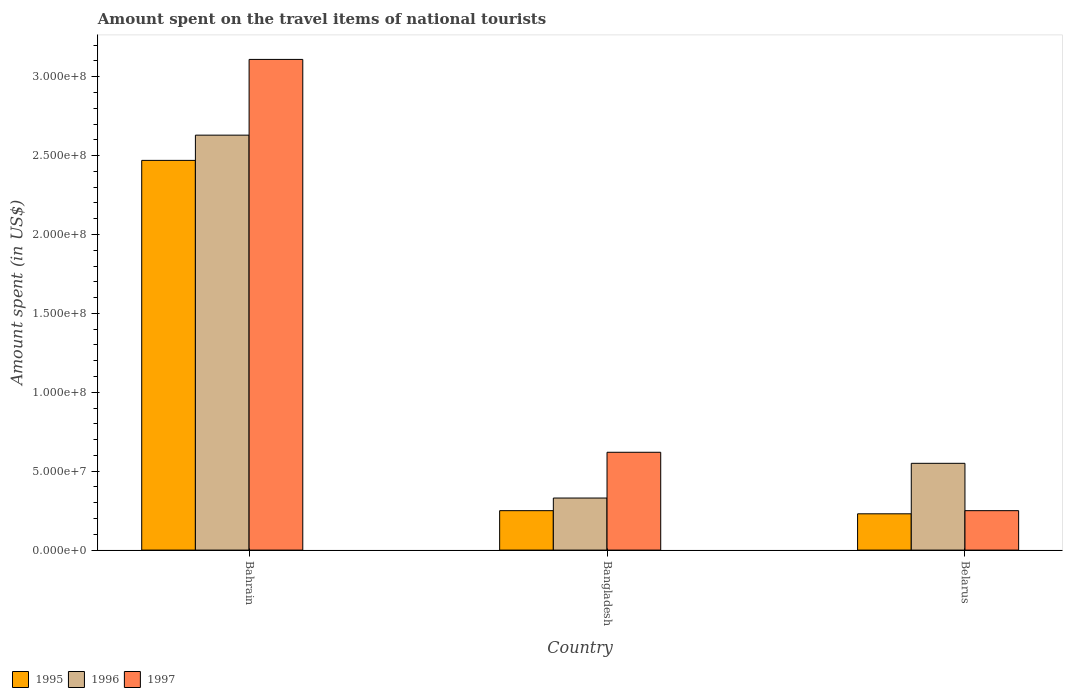How many different coloured bars are there?
Your answer should be compact. 3. What is the label of the 3rd group of bars from the left?
Offer a terse response. Belarus. What is the amount spent on the travel items of national tourists in 1996 in Belarus?
Offer a very short reply. 5.50e+07. Across all countries, what is the maximum amount spent on the travel items of national tourists in 1997?
Your response must be concise. 3.11e+08. Across all countries, what is the minimum amount spent on the travel items of national tourists in 1996?
Your answer should be compact. 3.30e+07. In which country was the amount spent on the travel items of national tourists in 1997 maximum?
Provide a succinct answer. Bahrain. In which country was the amount spent on the travel items of national tourists in 1995 minimum?
Make the answer very short. Belarus. What is the total amount spent on the travel items of national tourists in 1995 in the graph?
Ensure brevity in your answer.  2.95e+08. What is the difference between the amount spent on the travel items of national tourists in 1995 in Bahrain and that in Bangladesh?
Provide a short and direct response. 2.22e+08. What is the difference between the amount spent on the travel items of national tourists in 1996 in Bahrain and the amount spent on the travel items of national tourists in 1995 in Belarus?
Your answer should be compact. 2.40e+08. What is the average amount spent on the travel items of national tourists in 1997 per country?
Provide a succinct answer. 1.33e+08. What is the difference between the amount spent on the travel items of national tourists of/in 1995 and amount spent on the travel items of national tourists of/in 1996 in Bangladesh?
Make the answer very short. -8.00e+06. In how many countries, is the amount spent on the travel items of national tourists in 1996 greater than 60000000 US$?
Your answer should be very brief. 1. What is the ratio of the amount spent on the travel items of national tourists in 1995 in Bahrain to that in Bangladesh?
Make the answer very short. 9.88. What is the difference between the highest and the second highest amount spent on the travel items of national tourists in 1996?
Make the answer very short. 2.30e+08. What is the difference between the highest and the lowest amount spent on the travel items of national tourists in 1997?
Keep it short and to the point. 2.86e+08. Is the sum of the amount spent on the travel items of national tourists in 1996 in Bahrain and Bangladesh greater than the maximum amount spent on the travel items of national tourists in 1995 across all countries?
Ensure brevity in your answer.  Yes. What does the 3rd bar from the right in Belarus represents?
Offer a terse response. 1995. Is it the case that in every country, the sum of the amount spent on the travel items of national tourists in 1996 and amount spent on the travel items of national tourists in 1997 is greater than the amount spent on the travel items of national tourists in 1995?
Your response must be concise. Yes. How many bars are there?
Offer a very short reply. 9. How many countries are there in the graph?
Ensure brevity in your answer.  3. What is the difference between two consecutive major ticks on the Y-axis?
Offer a very short reply. 5.00e+07. Are the values on the major ticks of Y-axis written in scientific E-notation?
Offer a terse response. Yes. Does the graph contain any zero values?
Offer a very short reply. No. Does the graph contain grids?
Keep it short and to the point. No. How many legend labels are there?
Provide a short and direct response. 3. What is the title of the graph?
Make the answer very short. Amount spent on the travel items of national tourists. What is the label or title of the Y-axis?
Your response must be concise. Amount spent (in US$). What is the Amount spent (in US$) in 1995 in Bahrain?
Make the answer very short. 2.47e+08. What is the Amount spent (in US$) in 1996 in Bahrain?
Offer a terse response. 2.63e+08. What is the Amount spent (in US$) of 1997 in Bahrain?
Your response must be concise. 3.11e+08. What is the Amount spent (in US$) in 1995 in Bangladesh?
Your answer should be compact. 2.50e+07. What is the Amount spent (in US$) of 1996 in Bangladesh?
Offer a terse response. 3.30e+07. What is the Amount spent (in US$) of 1997 in Bangladesh?
Your answer should be compact. 6.20e+07. What is the Amount spent (in US$) in 1995 in Belarus?
Make the answer very short. 2.30e+07. What is the Amount spent (in US$) in 1996 in Belarus?
Your answer should be compact. 5.50e+07. What is the Amount spent (in US$) in 1997 in Belarus?
Ensure brevity in your answer.  2.50e+07. Across all countries, what is the maximum Amount spent (in US$) of 1995?
Provide a succinct answer. 2.47e+08. Across all countries, what is the maximum Amount spent (in US$) of 1996?
Provide a short and direct response. 2.63e+08. Across all countries, what is the maximum Amount spent (in US$) of 1997?
Your answer should be compact. 3.11e+08. Across all countries, what is the minimum Amount spent (in US$) in 1995?
Ensure brevity in your answer.  2.30e+07. Across all countries, what is the minimum Amount spent (in US$) of 1996?
Provide a short and direct response. 3.30e+07. Across all countries, what is the minimum Amount spent (in US$) of 1997?
Provide a short and direct response. 2.50e+07. What is the total Amount spent (in US$) of 1995 in the graph?
Make the answer very short. 2.95e+08. What is the total Amount spent (in US$) of 1996 in the graph?
Make the answer very short. 3.51e+08. What is the total Amount spent (in US$) of 1997 in the graph?
Your response must be concise. 3.98e+08. What is the difference between the Amount spent (in US$) in 1995 in Bahrain and that in Bangladesh?
Ensure brevity in your answer.  2.22e+08. What is the difference between the Amount spent (in US$) in 1996 in Bahrain and that in Bangladesh?
Make the answer very short. 2.30e+08. What is the difference between the Amount spent (in US$) of 1997 in Bahrain and that in Bangladesh?
Your answer should be very brief. 2.49e+08. What is the difference between the Amount spent (in US$) in 1995 in Bahrain and that in Belarus?
Provide a short and direct response. 2.24e+08. What is the difference between the Amount spent (in US$) in 1996 in Bahrain and that in Belarus?
Offer a terse response. 2.08e+08. What is the difference between the Amount spent (in US$) in 1997 in Bahrain and that in Belarus?
Keep it short and to the point. 2.86e+08. What is the difference between the Amount spent (in US$) in 1995 in Bangladesh and that in Belarus?
Give a very brief answer. 2.00e+06. What is the difference between the Amount spent (in US$) of 1996 in Bangladesh and that in Belarus?
Your answer should be very brief. -2.20e+07. What is the difference between the Amount spent (in US$) in 1997 in Bangladesh and that in Belarus?
Ensure brevity in your answer.  3.70e+07. What is the difference between the Amount spent (in US$) in 1995 in Bahrain and the Amount spent (in US$) in 1996 in Bangladesh?
Your answer should be compact. 2.14e+08. What is the difference between the Amount spent (in US$) in 1995 in Bahrain and the Amount spent (in US$) in 1997 in Bangladesh?
Offer a terse response. 1.85e+08. What is the difference between the Amount spent (in US$) in 1996 in Bahrain and the Amount spent (in US$) in 1997 in Bangladesh?
Make the answer very short. 2.01e+08. What is the difference between the Amount spent (in US$) of 1995 in Bahrain and the Amount spent (in US$) of 1996 in Belarus?
Give a very brief answer. 1.92e+08. What is the difference between the Amount spent (in US$) of 1995 in Bahrain and the Amount spent (in US$) of 1997 in Belarus?
Ensure brevity in your answer.  2.22e+08. What is the difference between the Amount spent (in US$) of 1996 in Bahrain and the Amount spent (in US$) of 1997 in Belarus?
Provide a short and direct response. 2.38e+08. What is the difference between the Amount spent (in US$) in 1995 in Bangladesh and the Amount spent (in US$) in 1996 in Belarus?
Offer a terse response. -3.00e+07. What is the difference between the Amount spent (in US$) of 1996 in Bangladesh and the Amount spent (in US$) of 1997 in Belarus?
Make the answer very short. 8.00e+06. What is the average Amount spent (in US$) in 1995 per country?
Give a very brief answer. 9.83e+07. What is the average Amount spent (in US$) in 1996 per country?
Provide a succinct answer. 1.17e+08. What is the average Amount spent (in US$) of 1997 per country?
Provide a short and direct response. 1.33e+08. What is the difference between the Amount spent (in US$) of 1995 and Amount spent (in US$) of 1996 in Bahrain?
Your answer should be compact. -1.60e+07. What is the difference between the Amount spent (in US$) of 1995 and Amount spent (in US$) of 1997 in Bahrain?
Your answer should be very brief. -6.40e+07. What is the difference between the Amount spent (in US$) in 1996 and Amount spent (in US$) in 1997 in Bahrain?
Your answer should be compact. -4.80e+07. What is the difference between the Amount spent (in US$) in 1995 and Amount spent (in US$) in 1996 in Bangladesh?
Your answer should be very brief. -8.00e+06. What is the difference between the Amount spent (in US$) in 1995 and Amount spent (in US$) in 1997 in Bangladesh?
Your answer should be compact. -3.70e+07. What is the difference between the Amount spent (in US$) in 1996 and Amount spent (in US$) in 1997 in Bangladesh?
Provide a short and direct response. -2.90e+07. What is the difference between the Amount spent (in US$) in 1995 and Amount spent (in US$) in 1996 in Belarus?
Provide a succinct answer. -3.20e+07. What is the difference between the Amount spent (in US$) of 1995 and Amount spent (in US$) of 1997 in Belarus?
Offer a very short reply. -2.00e+06. What is the difference between the Amount spent (in US$) in 1996 and Amount spent (in US$) in 1997 in Belarus?
Your response must be concise. 3.00e+07. What is the ratio of the Amount spent (in US$) in 1995 in Bahrain to that in Bangladesh?
Offer a very short reply. 9.88. What is the ratio of the Amount spent (in US$) in 1996 in Bahrain to that in Bangladesh?
Keep it short and to the point. 7.97. What is the ratio of the Amount spent (in US$) of 1997 in Bahrain to that in Bangladesh?
Your answer should be very brief. 5.02. What is the ratio of the Amount spent (in US$) in 1995 in Bahrain to that in Belarus?
Provide a short and direct response. 10.74. What is the ratio of the Amount spent (in US$) in 1996 in Bahrain to that in Belarus?
Keep it short and to the point. 4.78. What is the ratio of the Amount spent (in US$) of 1997 in Bahrain to that in Belarus?
Give a very brief answer. 12.44. What is the ratio of the Amount spent (in US$) of 1995 in Bangladesh to that in Belarus?
Your answer should be compact. 1.09. What is the ratio of the Amount spent (in US$) of 1997 in Bangladesh to that in Belarus?
Provide a short and direct response. 2.48. What is the difference between the highest and the second highest Amount spent (in US$) in 1995?
Offer a terse response. 2.22e+08. What is the difference between the highest and the second highest Amount spent (in US$) in 1996?
Make the answer very short. 2.08e+08. What is the difference between the highest and the second highest Amount spent (in US$) of 1997?
Offer a very short reply. 2.49e+08. What is the difference between the highest and the lowest Amount spent (in US$) of 1995?
Provide a succinct answer. 2.24e+08. What is the difference between the highest and the lowest Amount spent (in US$) of 1996?
Your answer should be very brief. 2.30e+08. What is the difference between the highest and the lowest Amount spent (in US$) of 1997?
Offer a terse response. 2.86e+08. 